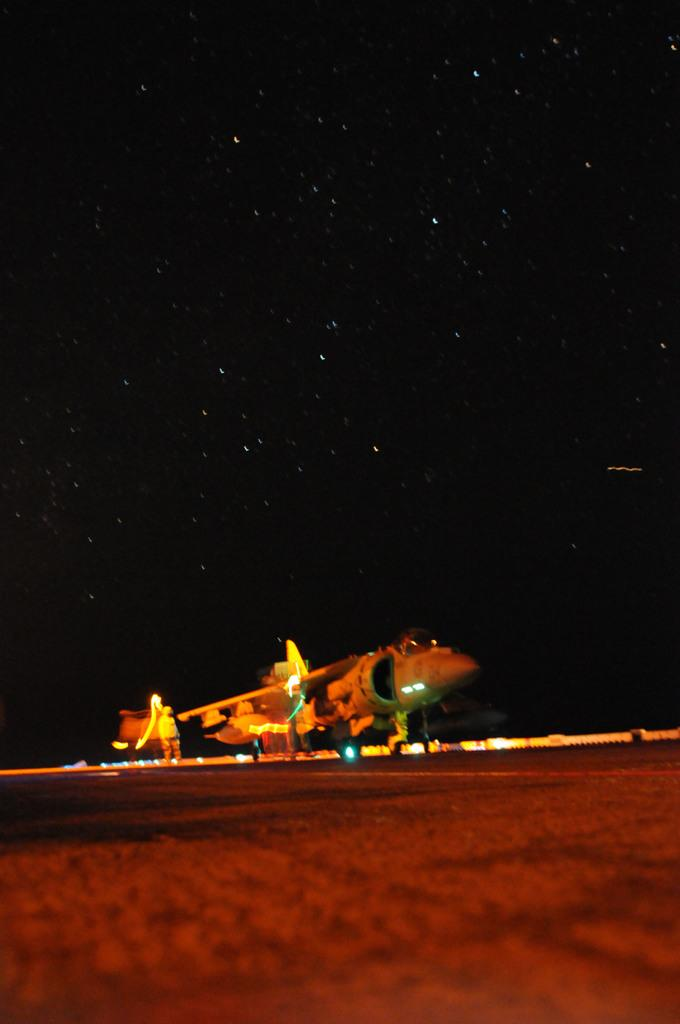What is the main subject of the image? The main subject of the image is an airplane. What else can be seen in the image besides the airplane? There are lights visible in the image, as well as a man on the ground. What is the background of the image? The background of the image includes stars in the sky. What type of account does the man on the ground have with the airplane in the image? There is no indication of any account or interaction between the man on the ground and the airplane in the image. Can you see a ball being thrown in the image? There is no ball present in the image. 